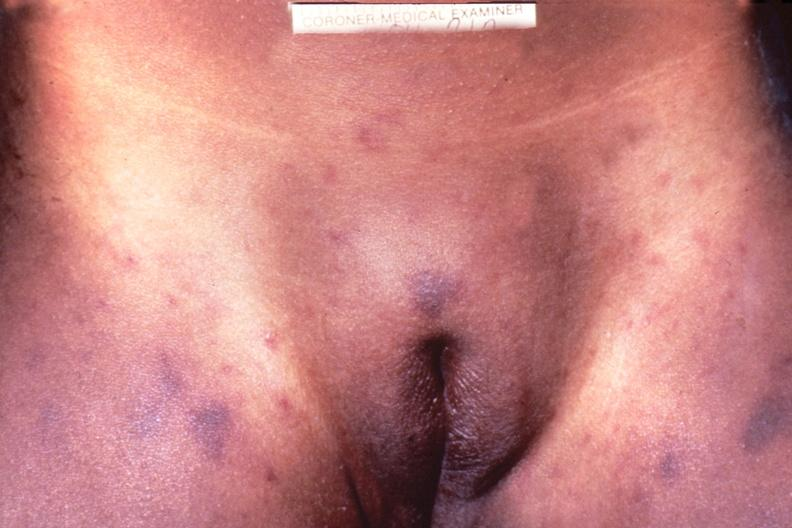what does this image show?
Answer the question using a single word or phrase. Meningococcemia 